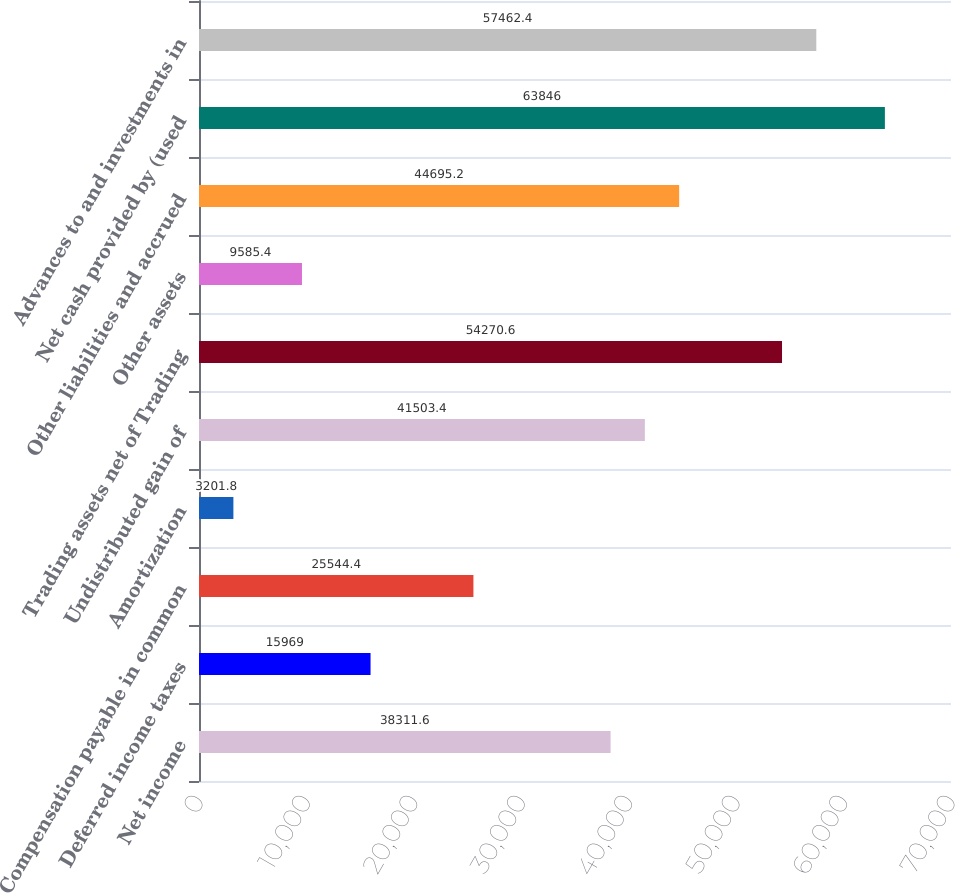<chart> <loc_0><loc_0><loc_500><loc_500><bar_chart><fcel>Net income<fcel>Deferred income taxes<fcel>Compensation payable in common<fcel>Amortization<fcel>Undistributed gain of<fcel>Trading assets net of Trading<fcel>Other assets<fcel>Other liabilities and accrued<fcel>Net cash provided by (used<fcel>Advances to and investments in<nl><fcel>38311.6<fcel>15969<fcel>25544.4<fcel>3201.8<fcel>41503.4<fcel>54270.6<fcel>9585.4<fcel>44695.2<fcel>63846<fcel>57462.4<nl></chart> 